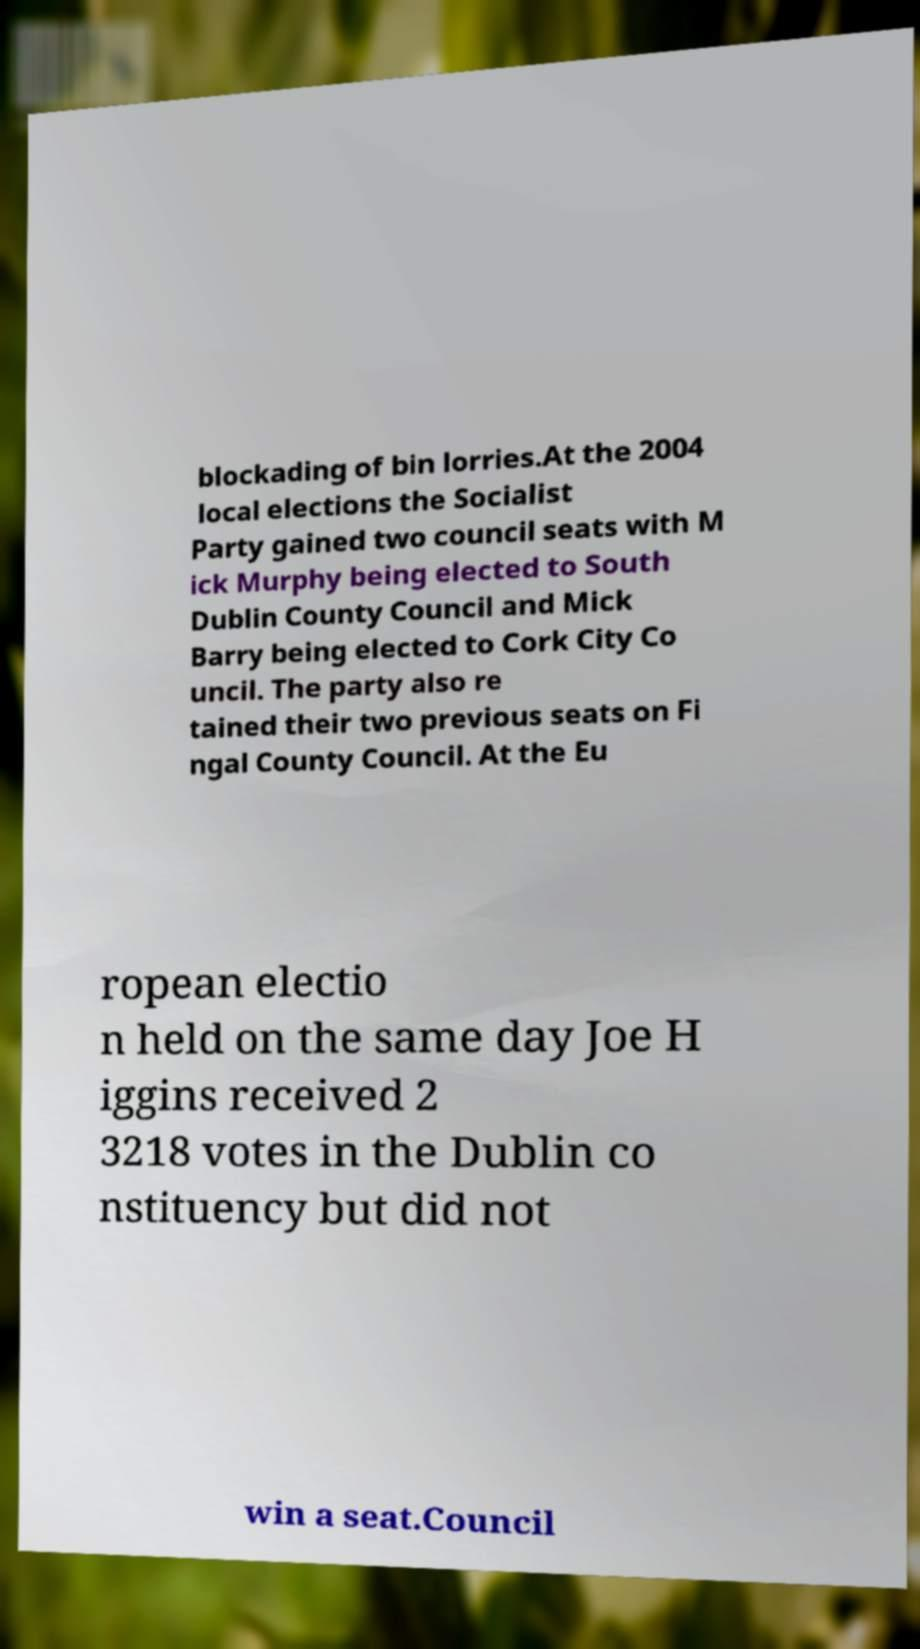Could you assist in decoding the text presented in this image and type it out clearly? blockading of bin lorries.At the 2004 local elections the Socialist Party gained two council seats with M ick Murphy being elected to South Dublin County Council and Mick Barry being elected to Cork City Co uncil. The party also re tained their two previous seats on Fi ngal County Council. At the Eu ropean electio n held on the same day Joe H iggins received 2 3218 votes in the Dublin co nstituency but did not win a seat.Council 